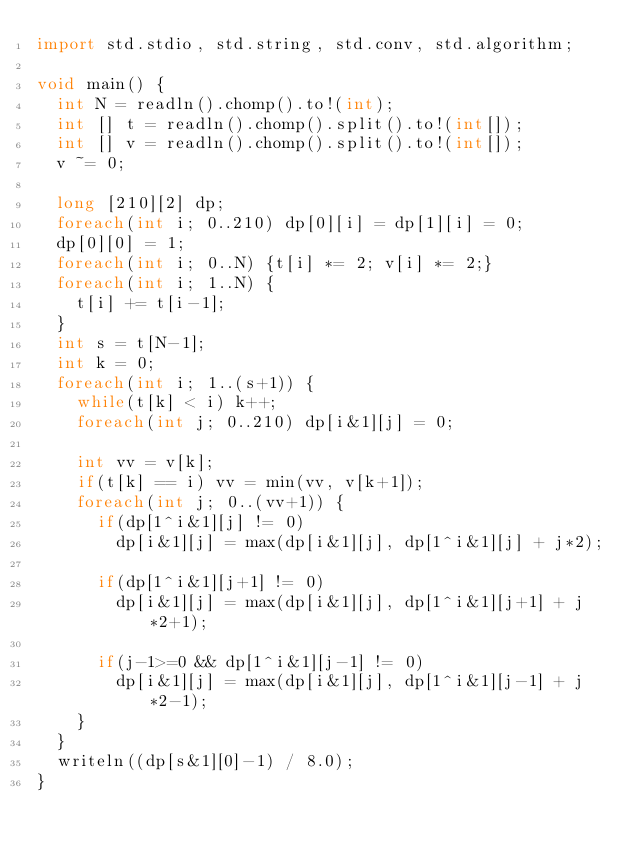<code> <loc_0><loc_0><loc_500><loc_500><_D_>import std.stdio, std.string, std.conv, std.algorithm;

void main() {
	int N = readln().chomp().to!(int);
	int [] t = readln().chomp().split().to!(int[]);
	int [] v = readln().chomp().split().to!(int[]);
	v ~= 0;

	long [210][2] dp;
	foreach(int i; 0..210) dp[0][i] = dp[1][i] = 0;
	dp[0][0] = 1;
	foreach(int i; 0..N) {t[i] *= 2; v[i] *= 2;}
	foreach(int i; 1..N) {
		t[i] += t[i-1];
	}
	int s = t[N-1];
	int k = 0;
	foreach(int i; 1..(s+1)) {
		while(t[k] < i) k++;
		foreach(int j; 0..210) dp[i&1][j] = 0;

		int vv = v[k];
		if(t[k] == i) vv = min(vv, v[k+1]);
		foreach(int j; 0..(vv+1)) {
			if(dp[1^i&1][j] != 0)
				dp[i&1][j] = max(dp[i&1][j], dp[1^i&1][j] + j*2);

			if(dp[1^i&1][j+1] != 0)
				dp[i&1][j] = max(dp[i&1][j], dp[1^i&1][j+1] + j*2+1);

			if(j-1>=0 && dp[1^i&1][j-1] != 0)
				dp[i&1][j] = max(dp[i&1][j], dp[1^i&1][j-1] + j*2-1);
		}
	}
	writeln((dp[s&1][0]-1) / 8.0);
}

</code> 